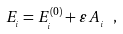Convert formula to latex. <formula><loc_0><loc_0><loc_500><loc_500>E _ { _ { i } } = E _ { _ { i } } ^ { ( 0 ) } + \varepsilon \, A _ { _ { i } } \ ,</formula> 